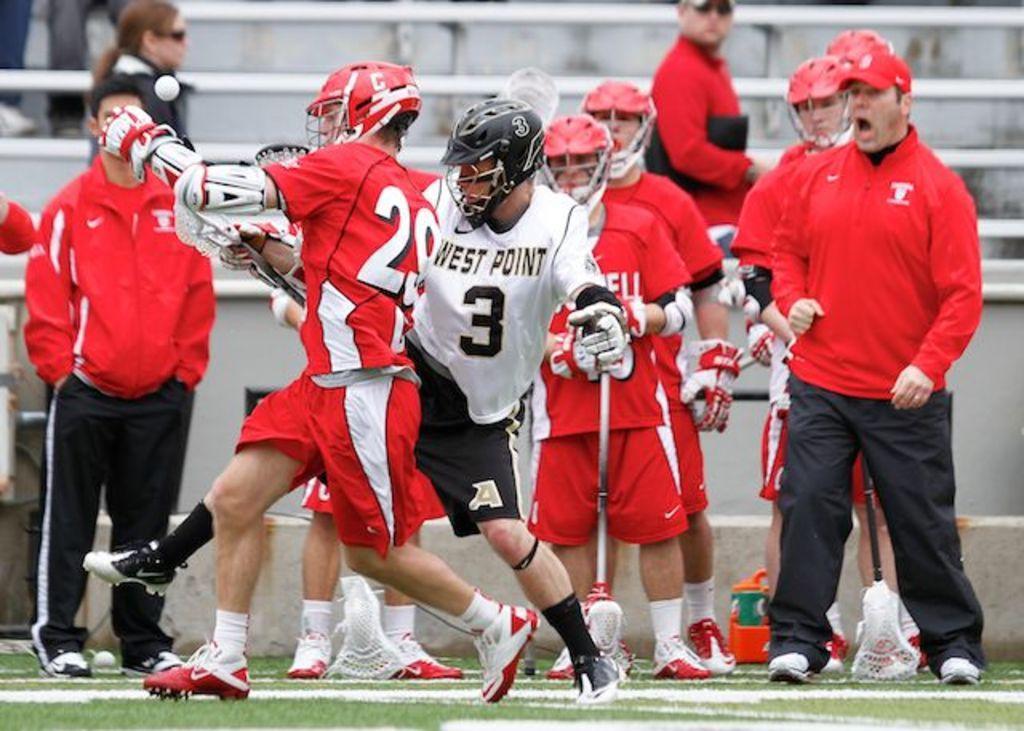In one or two sentences, can you explain what this image depicts? In the center of the image a group of people are standing, some of them are holding an object in their hand. In the background of the image stairs are there. At the bottom of the image ground is there. 